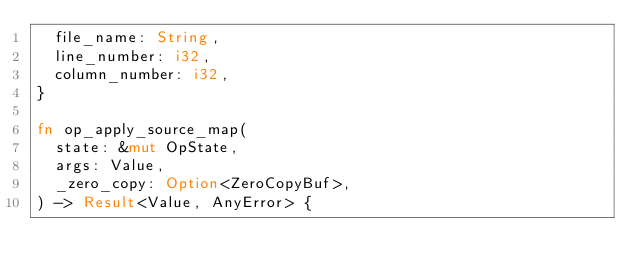Convert code to text. <code><loc_0><loc_0><loc_500><loc_500><_Rust_>  file_name: String,
  line_number: i32,
  column_number: i32,
}

fn op_apply_source_map(
  state: &mut OpState,
  args: Value,
  _zero_copy: Option<ZeroCopyBuf>,
) -> Result<Value, AnyError> {</code> 